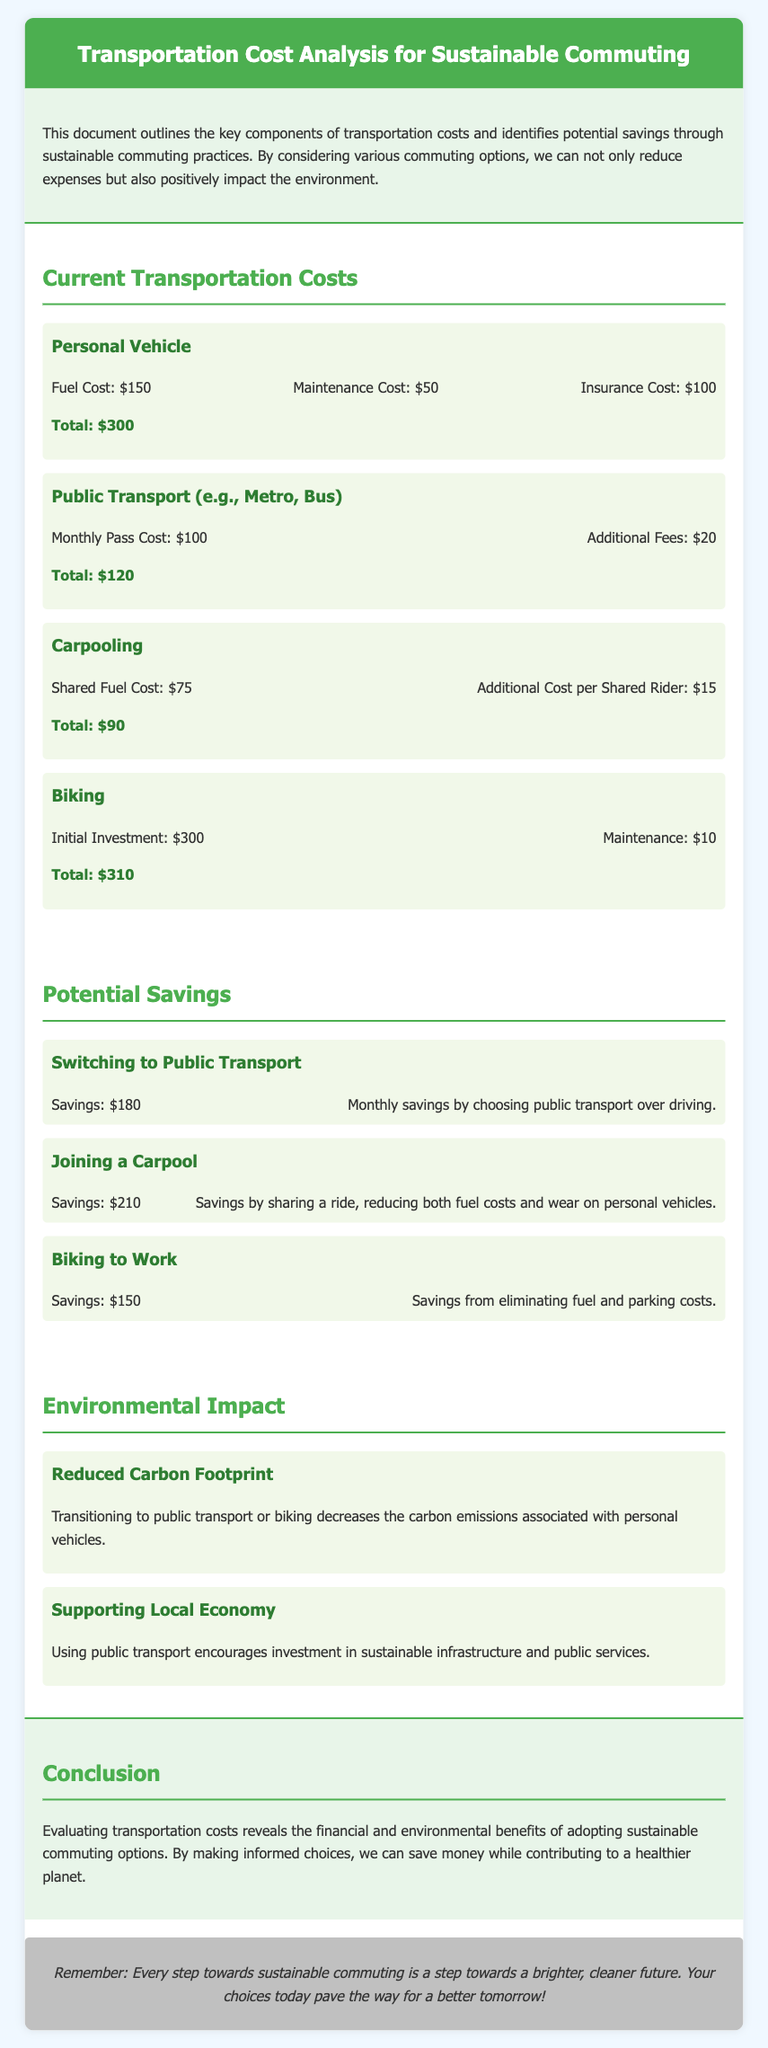What is the total cost of using a personal vehicle? The total cost for using a personal vehicle is detailed in the transportation costs section, which sums the fuel, maintenance, and insurance costs.
Answer: $300 What are the savings from switching to public transport? The potential savings from public transport are explicitly stated in the potential savings section, showing the financial benefit of this option.
Answer: $180 How much does carpooling save compared to a personal vehicle? The savings from joining a carpool are compared within the potential savings section, showing how it reduces overall commuting costs.
Answer: $210 What is the initial investment cost for biking? The biking cost details include an initial investment described in the transportation costs section, indicating this upfront expense.
Answer: $300 What are the environmental benefits of biking? The document mentions specific environmental impacts associated with transitioning to biking, emphasizing its positive contributions.
Answer: Reduced Carbon Footprint What type of transportation option has the lowest total cost? The total costs of each commuting option are compared altogether, providing a clear ranking of their affordability.
Answer: Carpooling What monthly transport option has additional fees? The section on public transport outlines that there are corresponding fees in addition to the standard pricing, highlighting the complete cost.
Answer: Additional Fees What is the conclusion about sustainable commuting? The conclusion section synthesizes the analysis, providing a summary statement regarding sustainable commuting choices and their impacts.
Answer: Save money while contributing to a healthier planet What are public transport’s costs in total? The total costs are collated in the transportation costs section to give a comprehensive view of monthly expenditures for public transport.
Answer: $120 